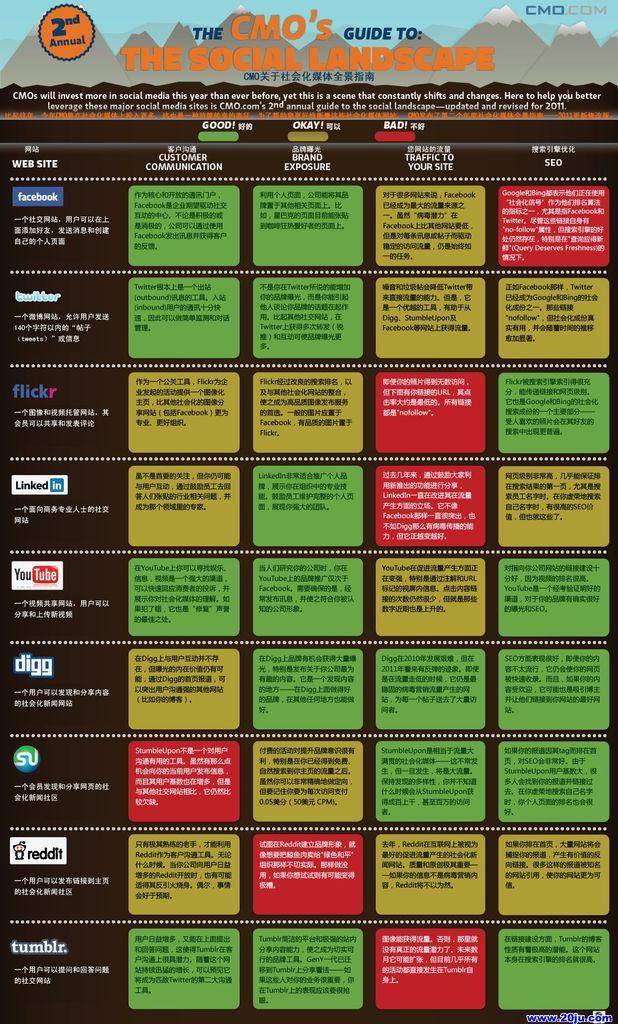Who's guide to the social landscape?
Your response must be concise. Cmo's. What color are the words "the social landscape" on this page?
Keep it short and to the point. Orange. 